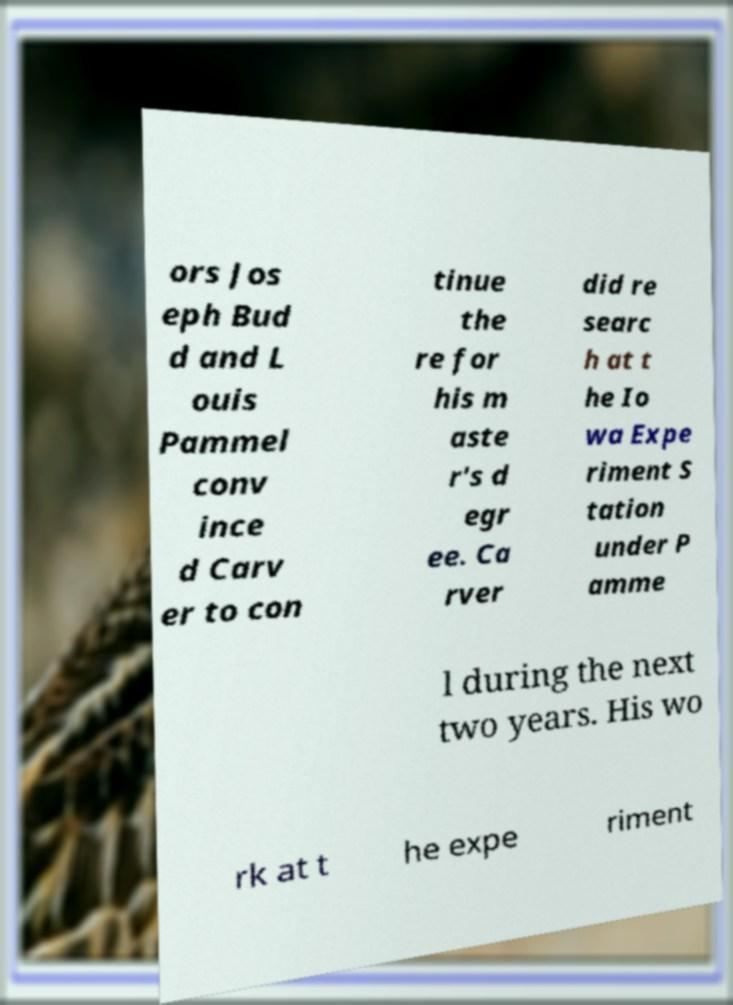Please read and relay the text visible in this image. What does it say? ors Jos eph Bud d and L ouis Pammel conv ince d Carv er to con tinue the re for his m aste r's d egr ee. Ca rver did re searc h at t he Io wa Expe riment S tation under P amme l during the next two years. His wo rk at t he expe riment 